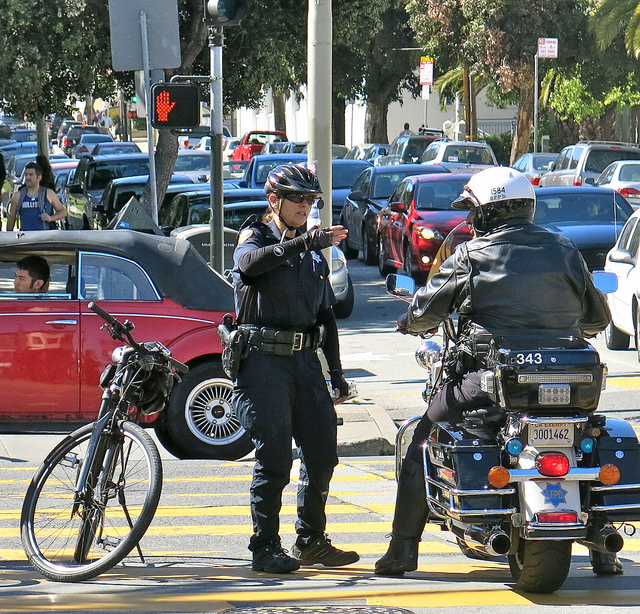What are they discussing?
A. gas cost
B. plans date
C. gun cost
D. traffic
Answer with the option's letter from the given choices directly. While there is no way to be certain about the specifics of their conversation, it is likely that they are discussing matters related to traffic or public safety, considering their roles as traffic officers and the context of the image showing cars and a pedestrian crossing. Therefore, a more suitable answer would be 'D. traffic'. 